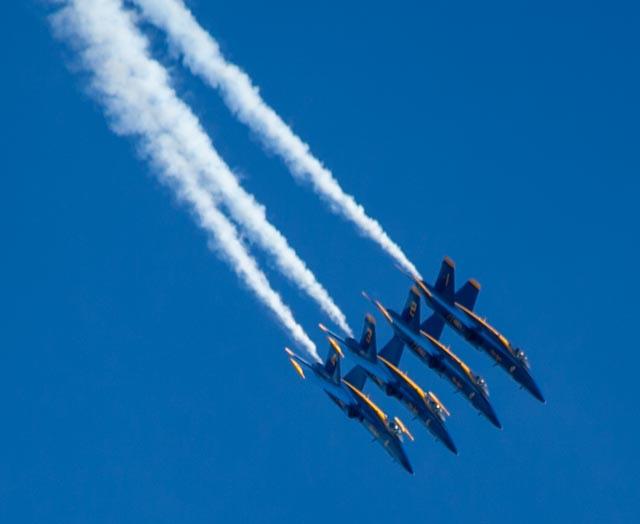What flying team is this?
Write a very short answer. Blue angels. Are all planes flying on the same altitude?
Answer briefly. Yes. How many planes do you see?
Keep it brief. 4. What is behind the planes?
Write a very short answer. Smoke. 